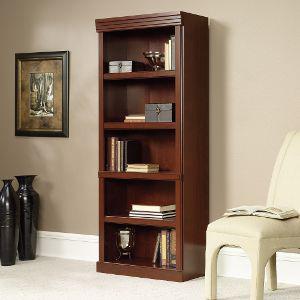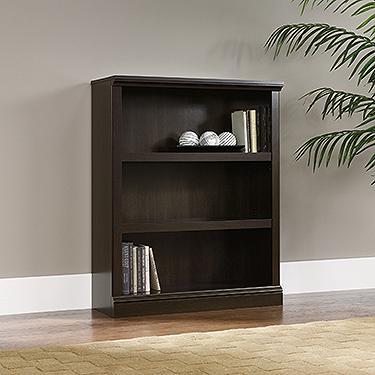The first image is the image on the left, the second image is the image on the right. For the images shown, is this caption "There are at least 3 or more shelves in the bookcases." true? Answer yes or no. Yes. The first image is the image on the left, the second image is the image on the right. Given the left and right images, does the statement "There is 1 ivory colored chair next to a tall bookcase." hold true? Answer yes or no. Yes. 